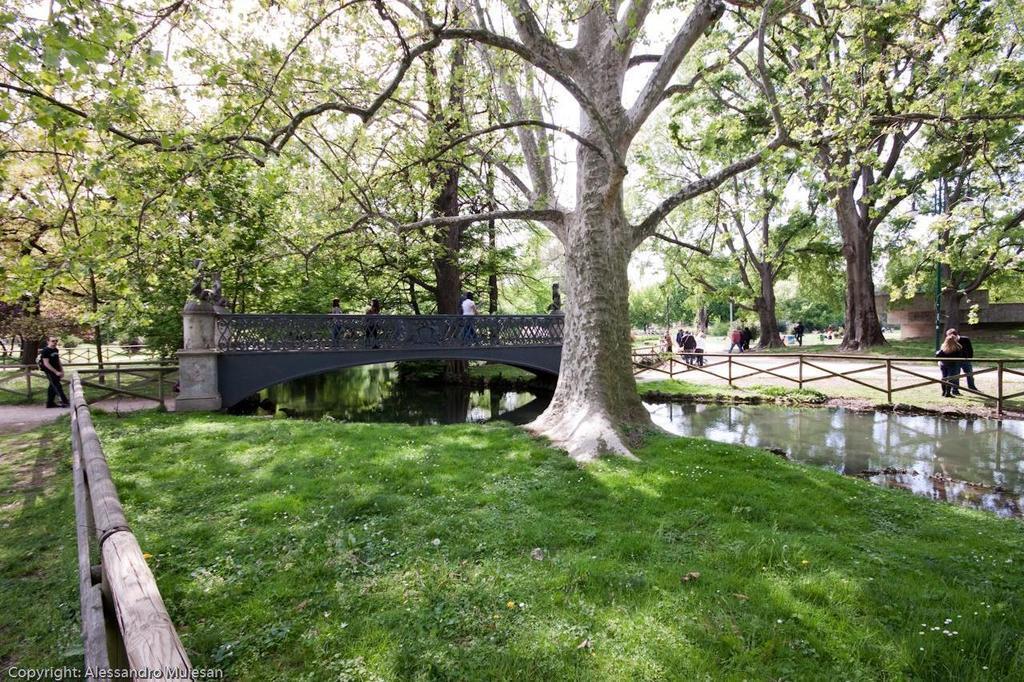Describe this image in one or two sentences. In this picture I can see there is grass on the surface on the floor and there is a wooden frame onto the left side, there is a bridge in the backdrop and there are few people walking on the bridge and there is a lake at right side and it looks like there is a building on right side. 